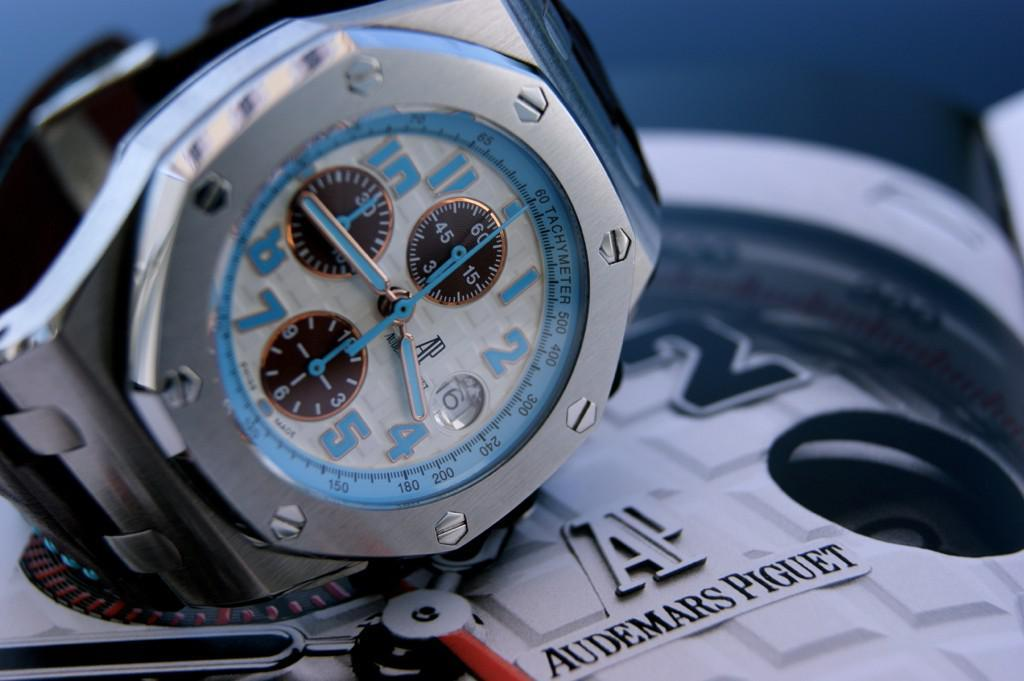<image>
Relay a brief, clear account of the picture shown. A watch sits on a larger watch by Audemars Piguet. 